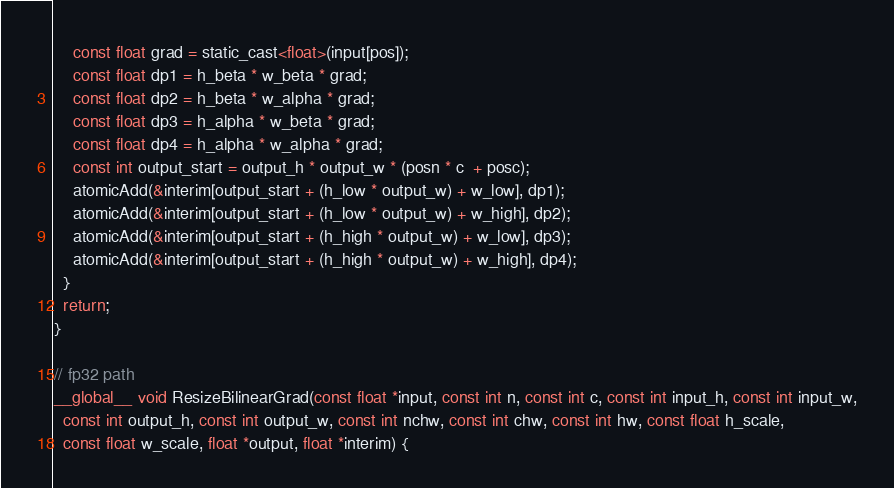Convert code to text. <code><loc_0><loc_0><loc_500><loc_500><_Cuda_>    const float grad = static_cast<float>(input[pos]);
    const float dp1 = h_beta * w_beta * grad;
    const float dp2 = h_beta * w_alpha * grad;
    const float dp3 = h_alpha * w_beta * grad;
    const float dp4 = h_alpha * w_alpha * grad;
    const int output_start = output_h * output_w * (posn * c  + posc);
    atomicAdd(&interim[output_start + (h_low * output_w) + w_low], dp1);
    atomicAdd(&interim[output_start + (h_low * output_w) + w_high], dp2);
    atomicAdd(&interim[output_start + (h_high * output_w) + w_low], dp3);
    atomicAdd(&interim[output_start + (h_high * output_w) + w_high], dp4);
  }
  return;
}

// fp32 path
__global__ void ResizeBilinearGrad(const float *input, const int n, const int c, const int input_h, const int input_w,
  const int output_h, const int output_w, const int nchw, const int chw, const int hw, const float h_scale,
  const float w_scale, float *output, float *interim) {</code> 